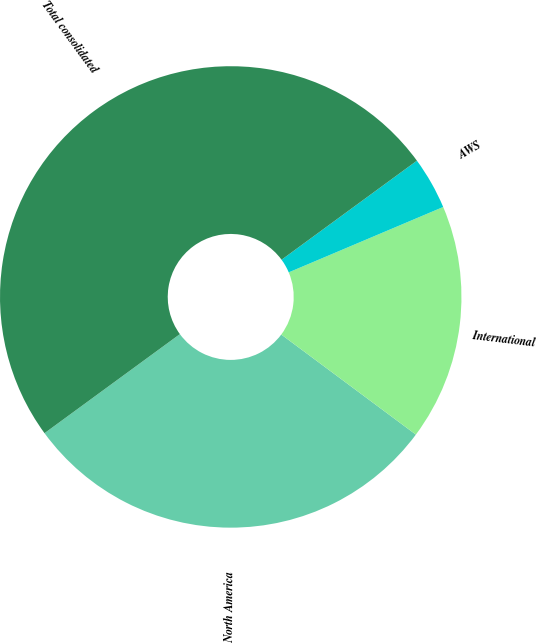Convert chart to OTSL. <chart><loc_0><loc_0><loc_500><loc_500><pie_chart><fcel>North America<fcel>International<fcel>AWS<fcel>Total consolidated<nl><fcel>29.77%<fcel>16.55%<fcel>3.68%<fcel>50.0%<nl></chart> 